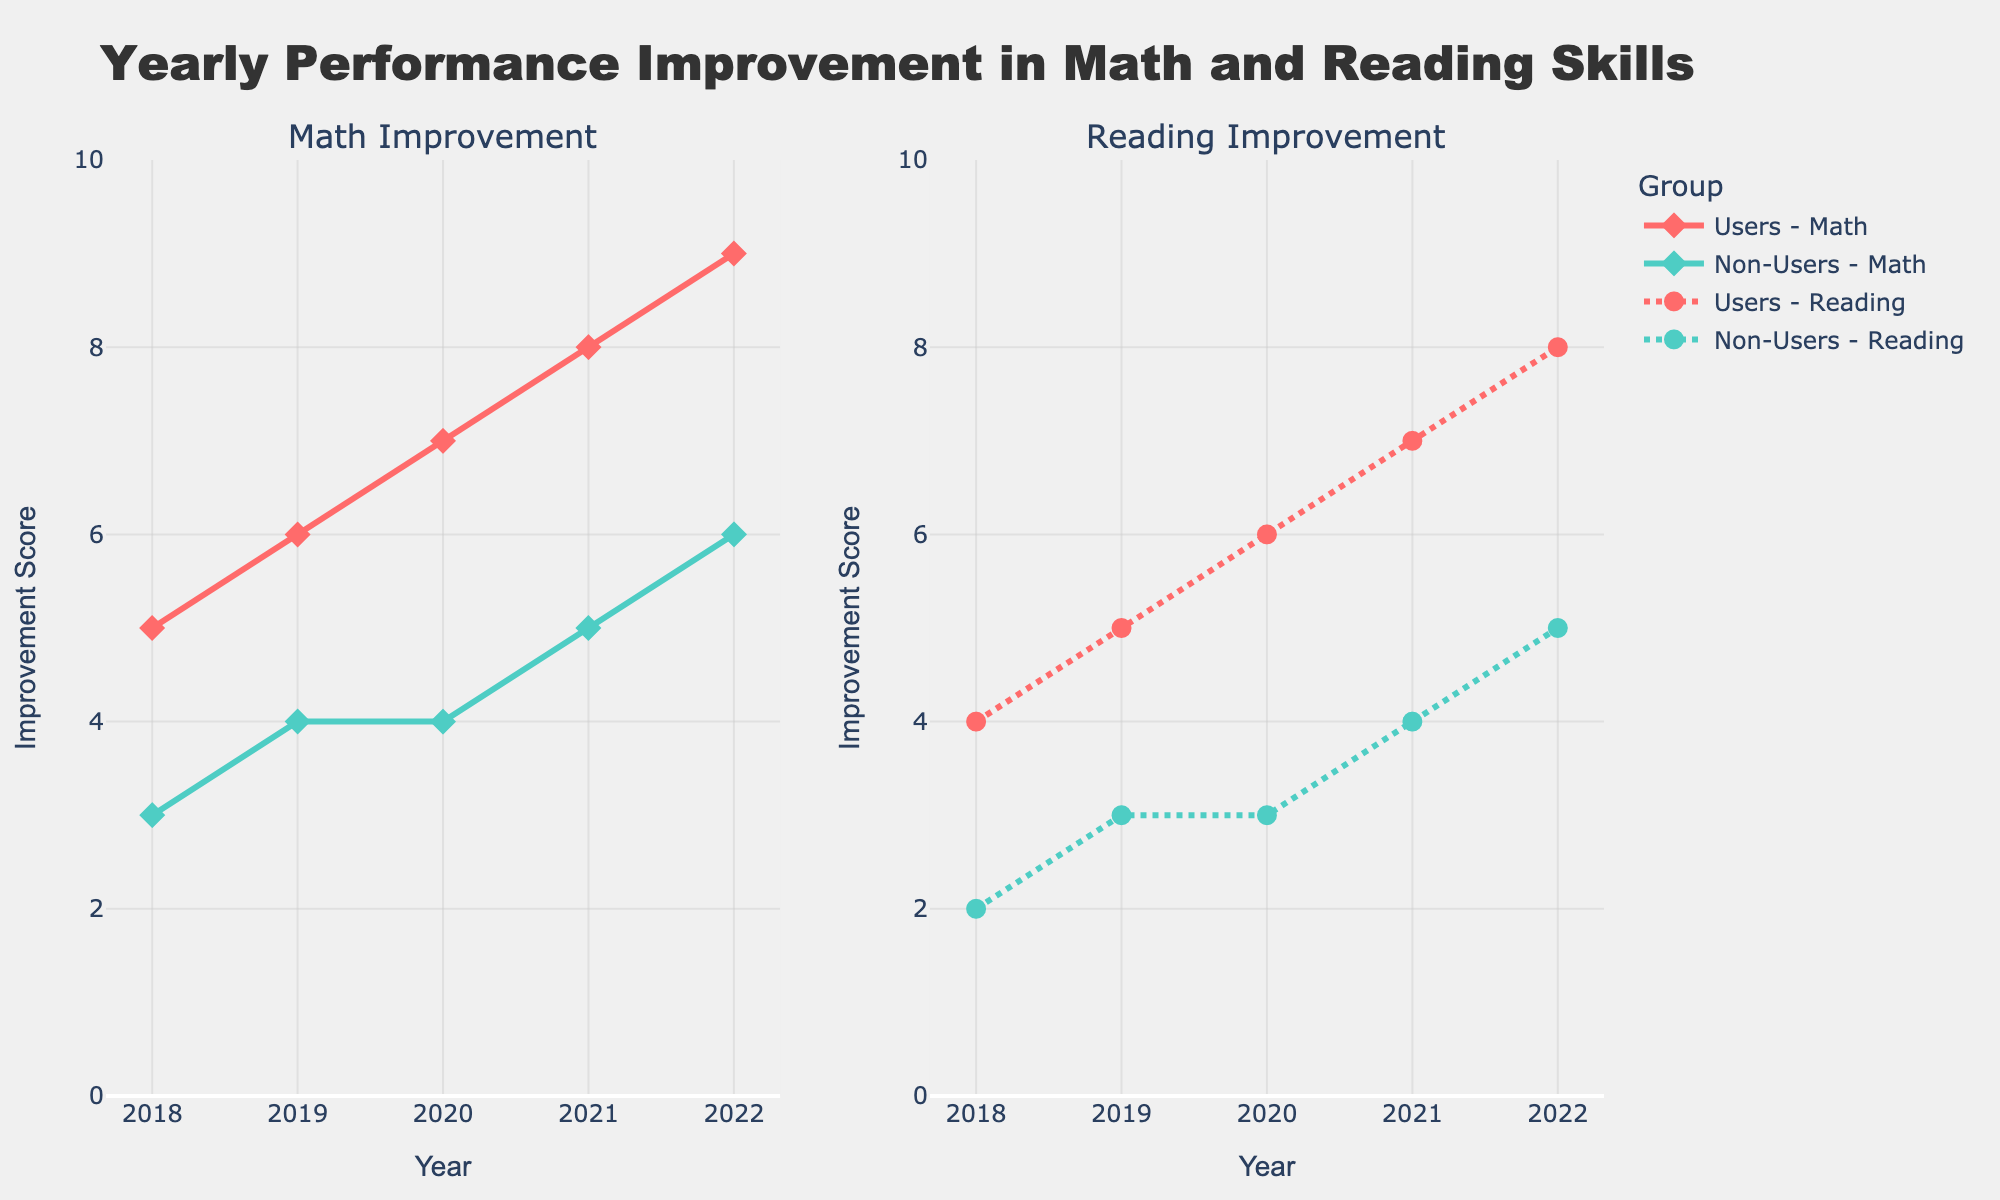What's the title of the plot? The title is displayed at the top of the plot. It reads "Yearly Performance Improvement in Math and Reading Skills".
Answer: Yearly Performance Improvement in Math and Reading Skills What are the two subplots focusing on? The subplot titles indicate that the left subplot shows "Math Improvement" and the right subplot shows "Reading Improvement".
Answer: Math Improvement and Reading Improvement What is the range of the y-axis? The y-axis ranges from 0 to 10, as indicated by the y-axis labels.
Answer: 0 to 10 How has the math improvement score for users changed from 2018 to 2022? From 2018 to 2022, the math improvement score for users has increased each year: from 5 in 2018, 6 in 2019, 7 in 2020, 8 in 2021, to 9 in 2022.
Answer: Increased from 5 to 9 Which group had a higher reading improvement score in 2020, users or non-users? In the 2020 plot for reading improvement, users have a score of 6 while non-users have a score of 3.
Answer: Users What are the shapes of the markers used for users and non-users in both subplots? In both subplots, the markers for users are diamonds, and the markers for non-users are circles.
Answer: Diamonds for users and circles for non-users How many years of data are shown in the plot? The x-axis lists five years: 2018, 2019, 2020, 2021, and 2022, so there are five years of data.
Answer: Five years Calculate the average reading improvement score for non-users from 2018 to 2022. The reading improvement scores for non-users from 2018 to 2022 are 2, 3, 3, 4, and 5. The sum is 2 + 3 + 3 + 4 + 5 = 17, and the average is 17/5 = 3.4.
Answer: 3.4 What difference can be observed in the trend of math improvement scores between users and non-users? Users' scores increase steadily each year from 2018 to 2022. Non-users' scores increase less visibly, with smaller increments.
Answer: Users show steady increases, non-users less so Which year shows the largest gap in reading improvement scores between users and non-users? In 2020, users have a reading improvement score of 6 and non-users have a score of 3. The gap is 6 - 3 = 3, which is the largest difference observed.
Answer: 2020 